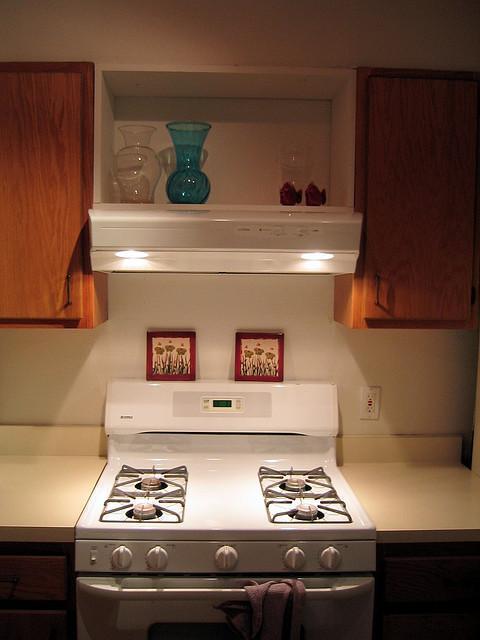What does the middle knob on the stove turn on?
Indicate the correct response by choosing from the four available options to answer the question.
Options: Oven, right burners, timer, left burners. Oven. 